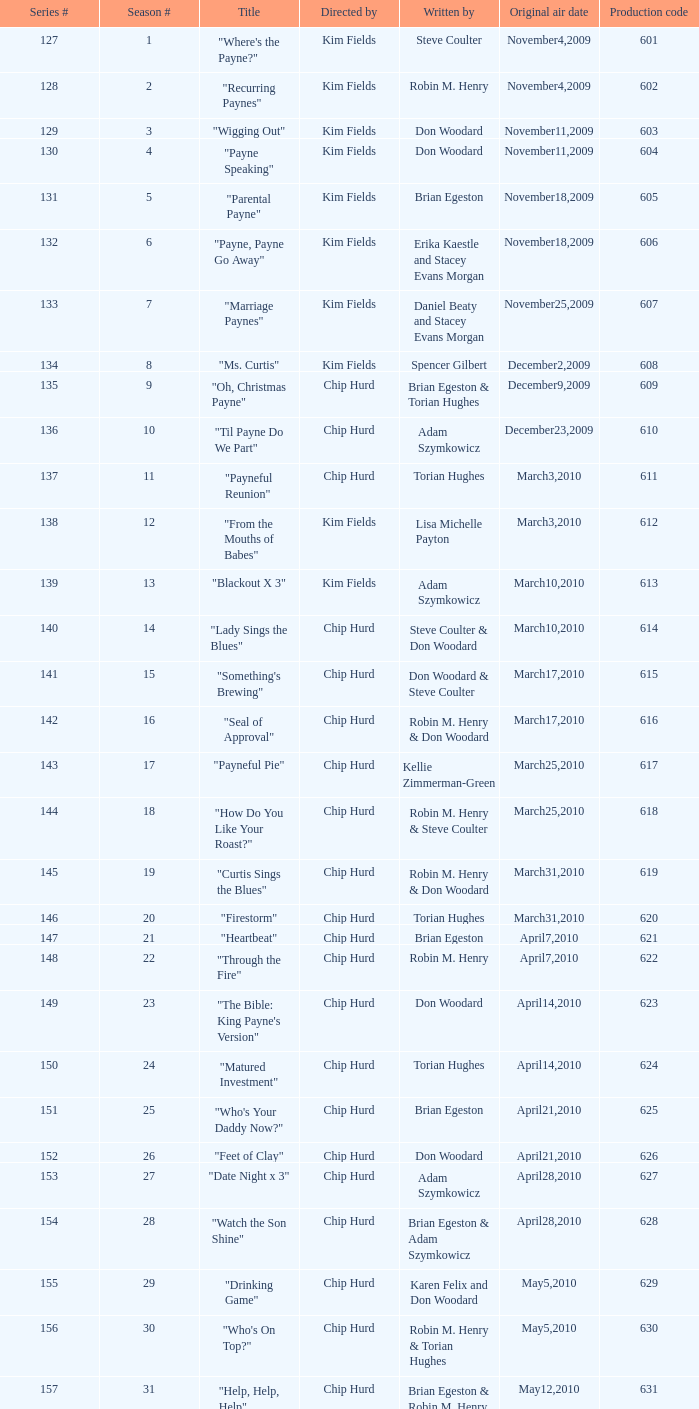On what date was the episode penned by karen felix and don woodard first broadcasted? May5,2010. 